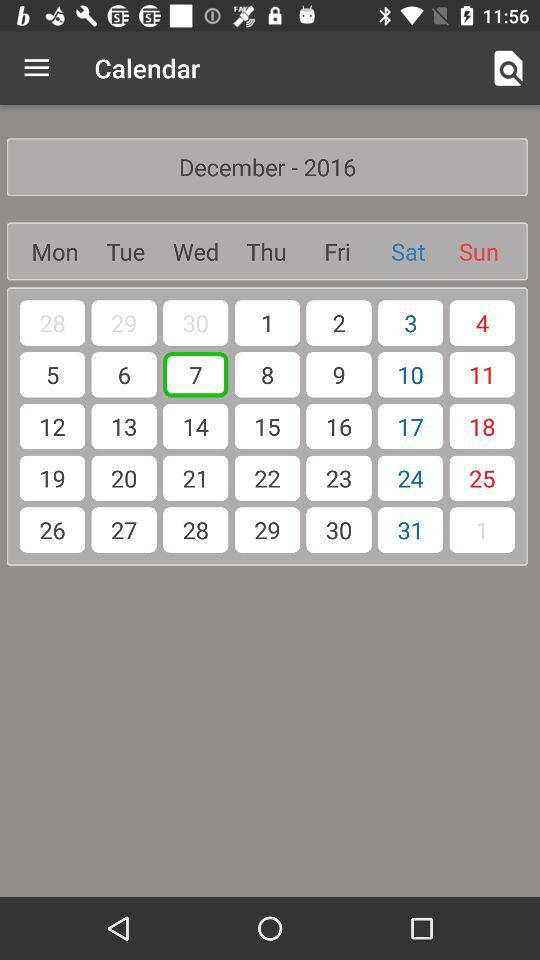What is the selected date? The selected date is Wednesday, December 7, 2016. 